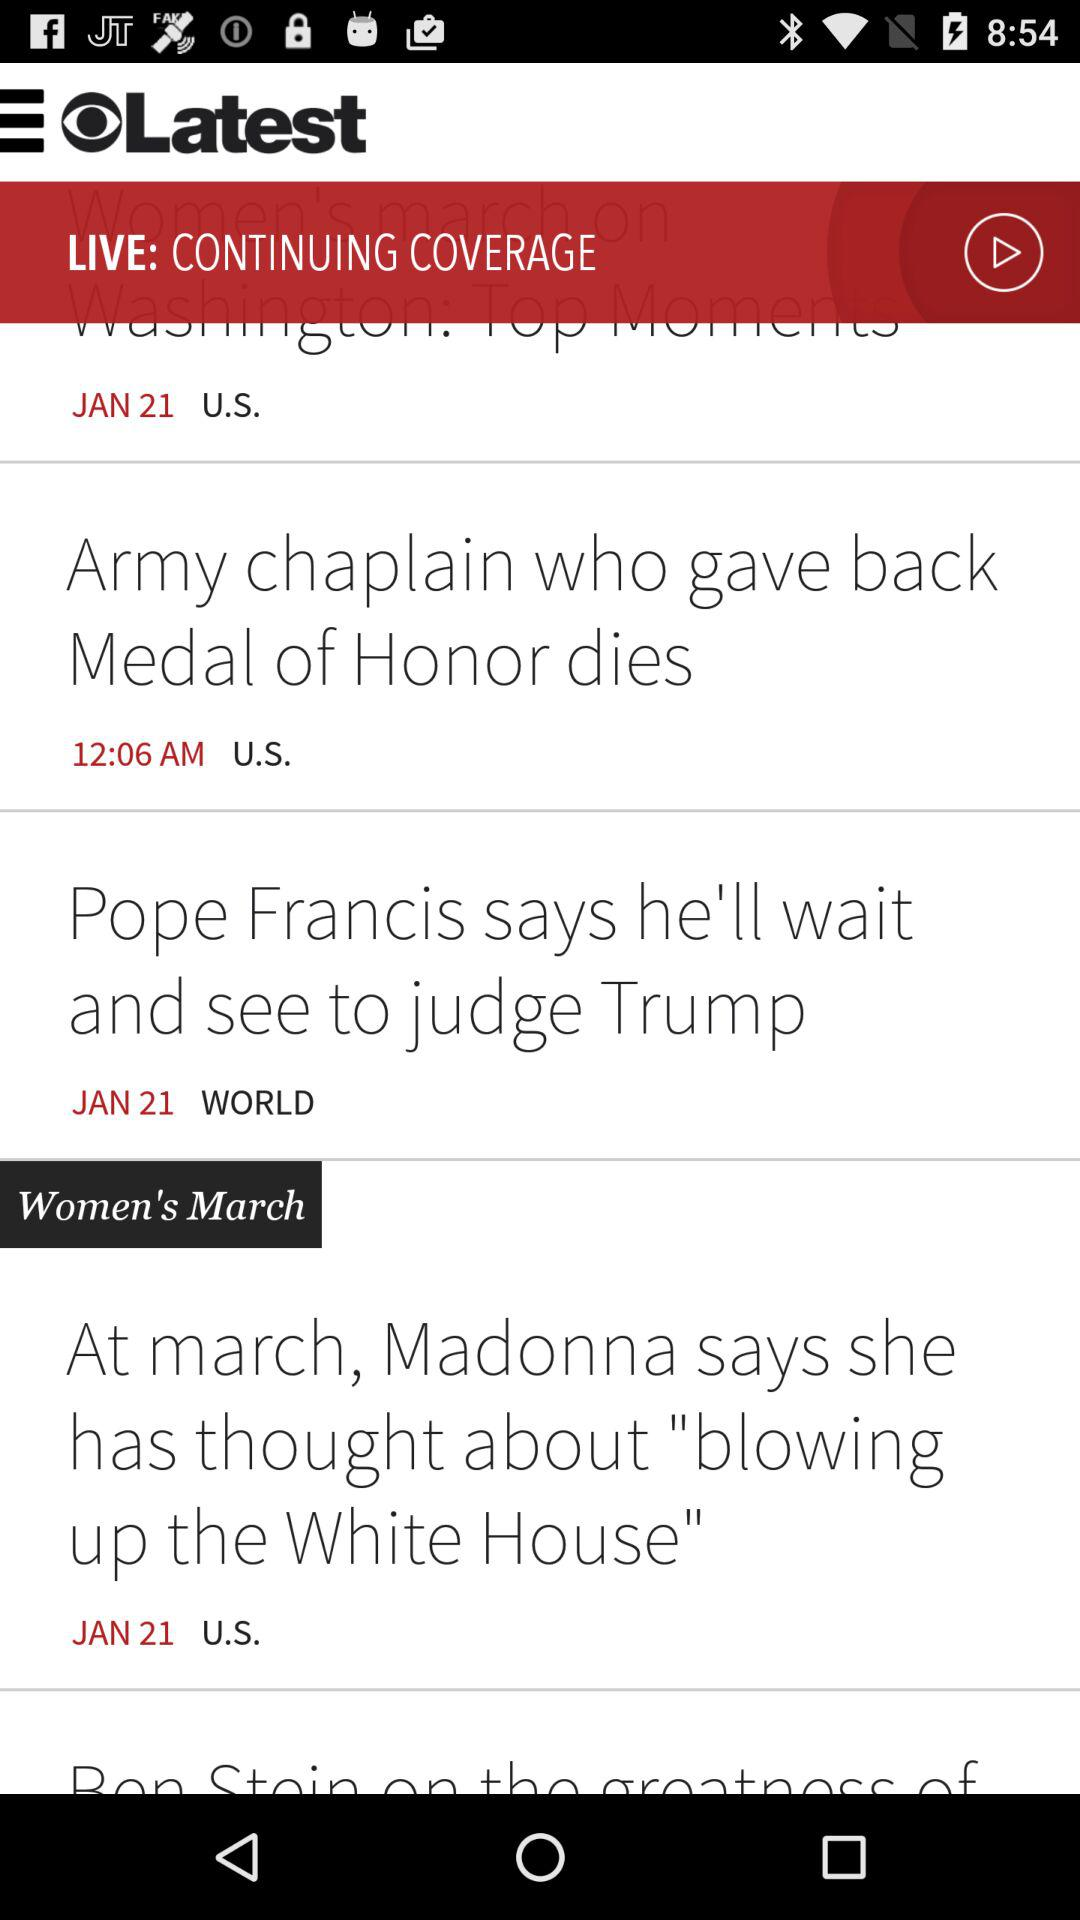What was the time of the news published? The time was 12:06 AM. 